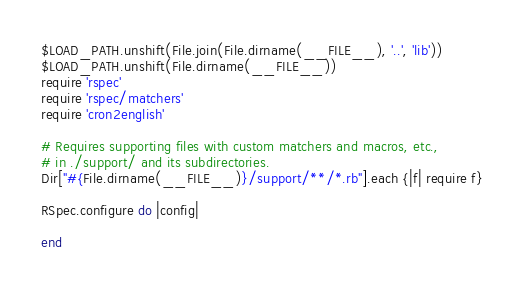<code> <loc_0><loc_0><loc_500><loc_500><_Ruby_>$LOAD_PATH.unshift(File.join(File.dirname(__FILE__), '..', 'lib'))
$LOAD_PATH.unshift(File.dirname(__FILE__))
require 'rspec'
require 'rspec/matchers'
require 'cron2english'

# Requires supporting files with custom matchers and macros, etc.,
# in ./support/ and its subdirectories.
Dir["#{File.dirname(__FILE__)}/support/**/*.rb"].each {|f| require f}

RSpec.configure do |config|

end

</code> 